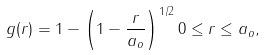Convert formula to latex. <formula><loc_0><loc_0><loc_500><loc_500>g ( r ) = 1 - \left ( 1 - \frac { r } { a _ { o } } \right ) ^ { 1 / 2 } 0 \leq r \leq a _ { o } ,</formula> 